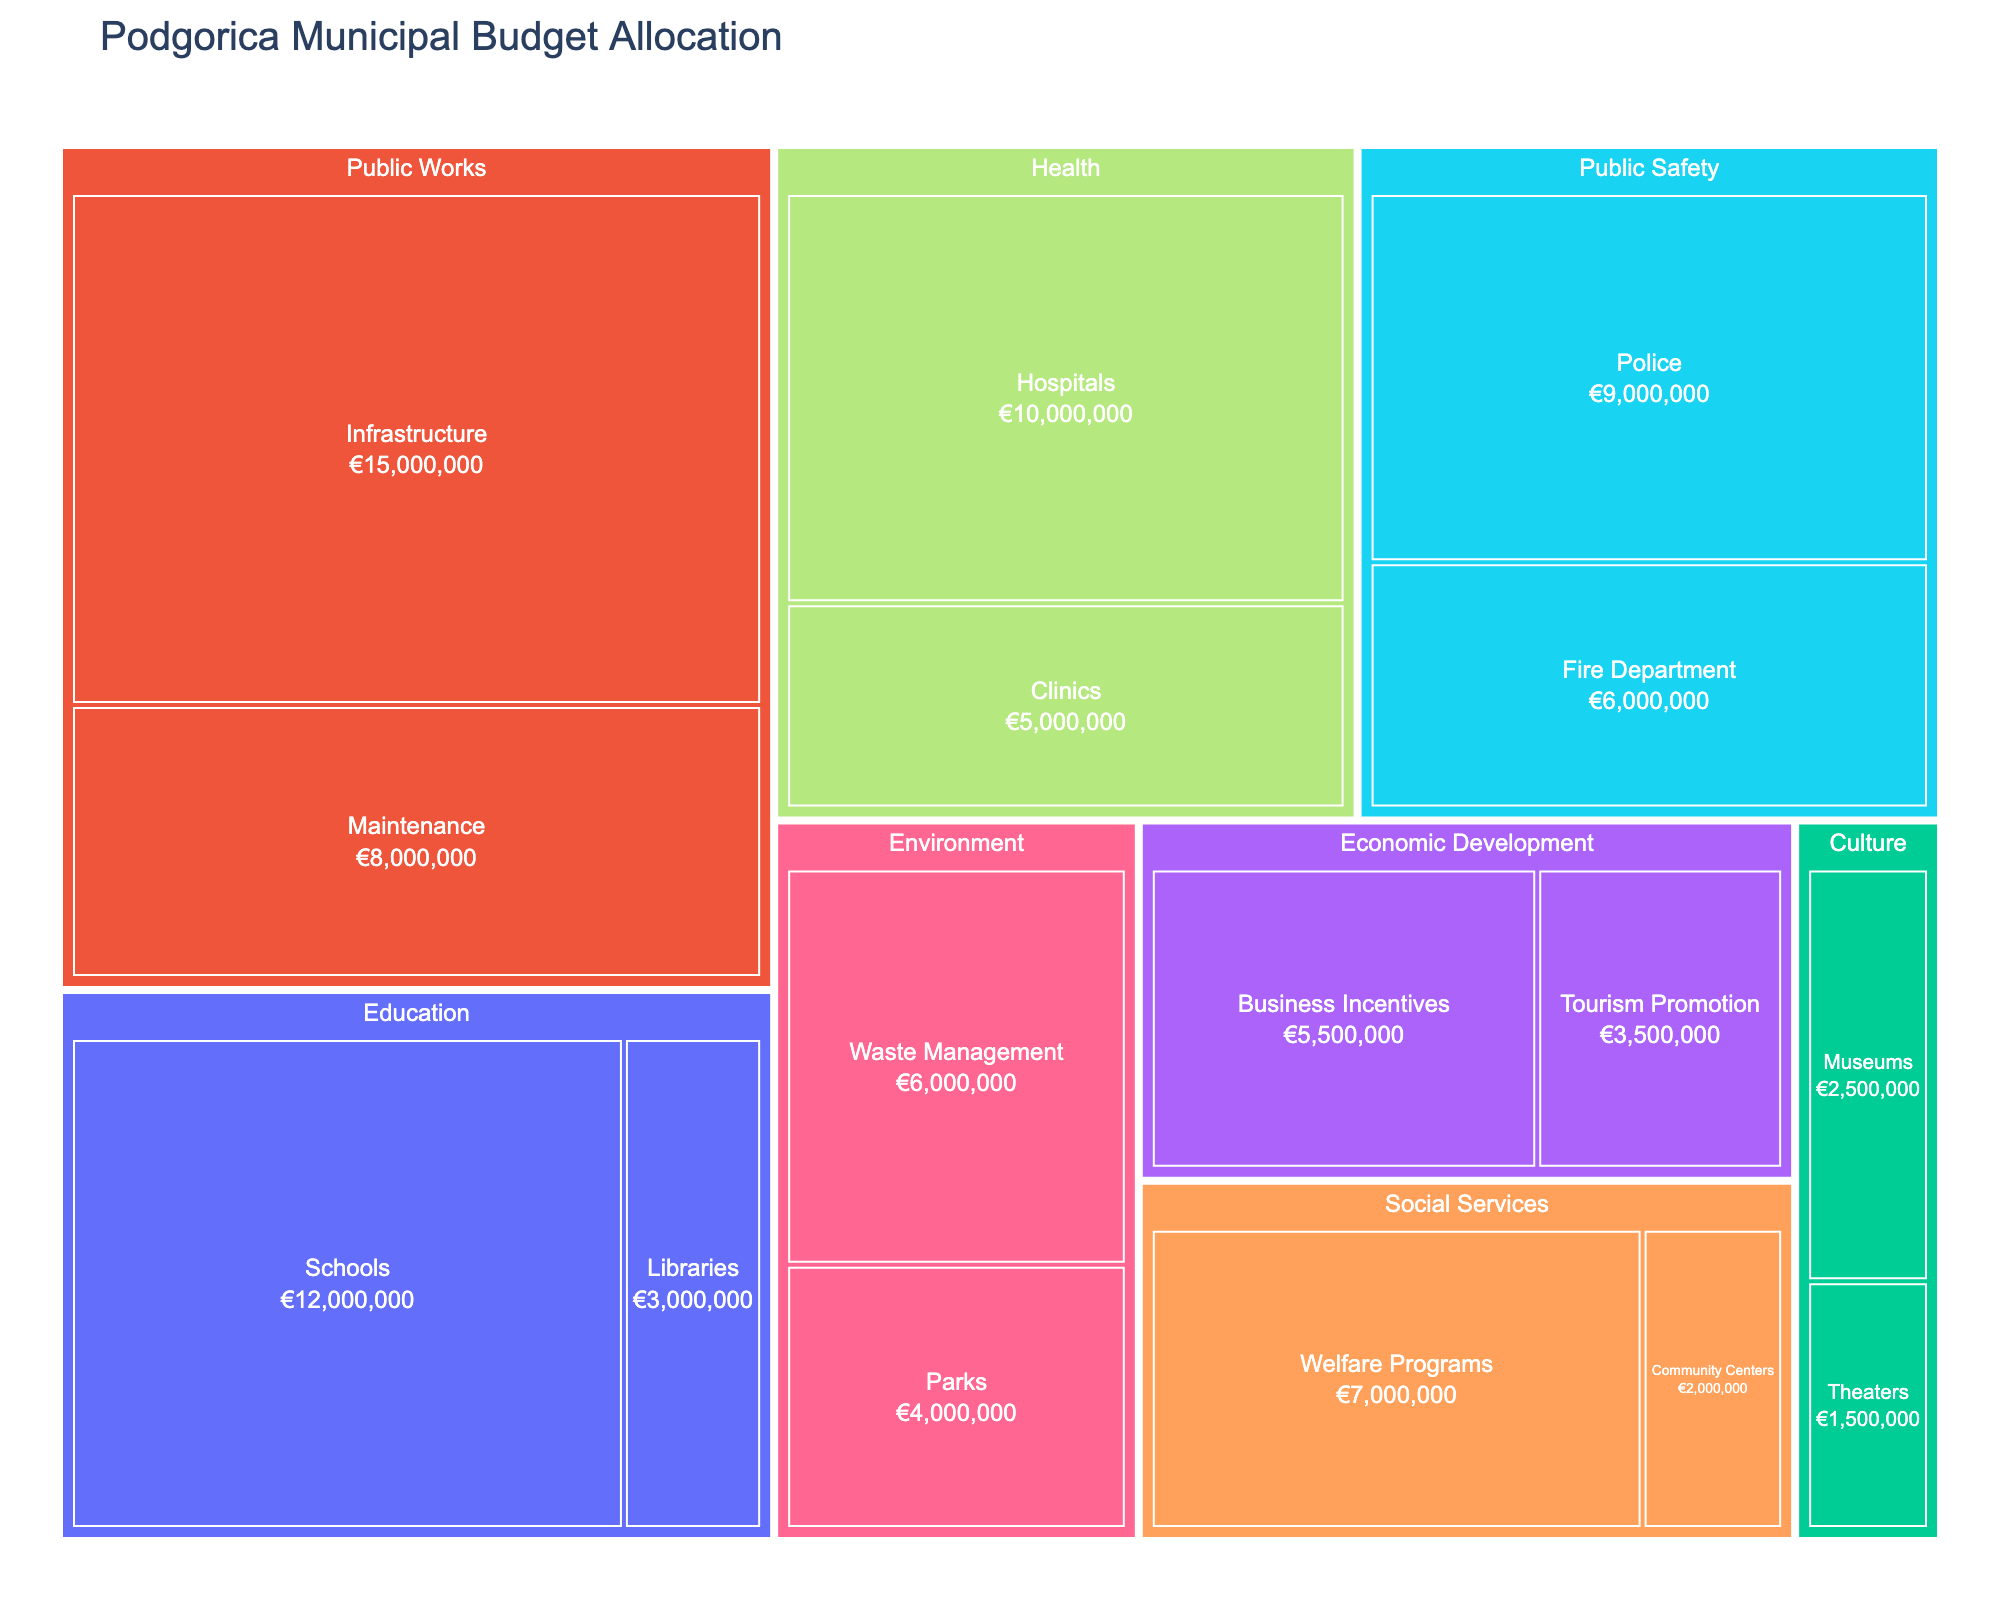What is the title of the treemap? The title of the treemap is usually displayed prominently at the top. In this case, it is indicated in the code as 'Podgorica Municipal Budget Allocation'.
Answer: Podgorica Municipal Budget Allocation Which department has the largest overall budget? To find the department with the largest overall budget, we can compare the size of the different sections in the treemap. By reviewing the data, 'Public Works' has the largest budget with €23,000,000 (€15,000,000 + €8,000,000).
Answer: Public Works What is the smallest budgeted category in the Culture department? Within the Culture department, the categories are Museums and Theaters. Theaters have a budget of €1,500,000, which is smaller than Museums with €2,500,000.
Answer: Theaters How much budget is allocated to Infrastructure across all sectors? According to the data, the only mention of Infrastructure occurs in the Public Works category with the budget of €15,000,000. Therefore, the total allocation for Infrastructure is €15,000,000.
Answer: €15,000,000 What is the total budget allocated to Education? The Education department has two categories: Schools (€12,000,000) and Libraries (€3,000,000). Adding these amounts gives us a total of €15,000,000.
Answer: €15,000,000 Which sectors in Public Safety receive the budget? The Public Safety department includes the Police with a budget of €9,000,000 and the Fire Department with €6,000,000. The treemap will visually show these two sectors.
Answer: Police and Fire Department Compare the budget allocation for Parks and Waste Management. Which one is higher? The Environment department includes Parks (€4,000,000) and Waste Management (€6,000,000). The allocation for Waste Management is higher.
Answer: Waste Management What is the budget difference between Welfare Programs and Community Centers in Social Services? The Social Services department includes Welfare Programs (€7,000,000) and Community Centers (€2,000,000). The difference is calculated by subtracting the smaller value from the larger.
Answer: €5,000,000 Which has a larger budget: Museums or Business Incentives? The Culture department's Museums category has a budget of €2,500,000, while the Economic Development's Business Incentives category has a budget of €5,500,000. Business Incentives has a larger budget.
Answer: Business Incentives What percentage of the total budget is allocated to Healthcare? The Health department receives a total budget of €15,000,000 (Hospitals €10,000,000 + Clinics €5,000,000). The total budget across all departments is €99,500,000. The percentage is calculated as (15,000,000 / 99,500,000) * 100%.
Answer: 15.08% 